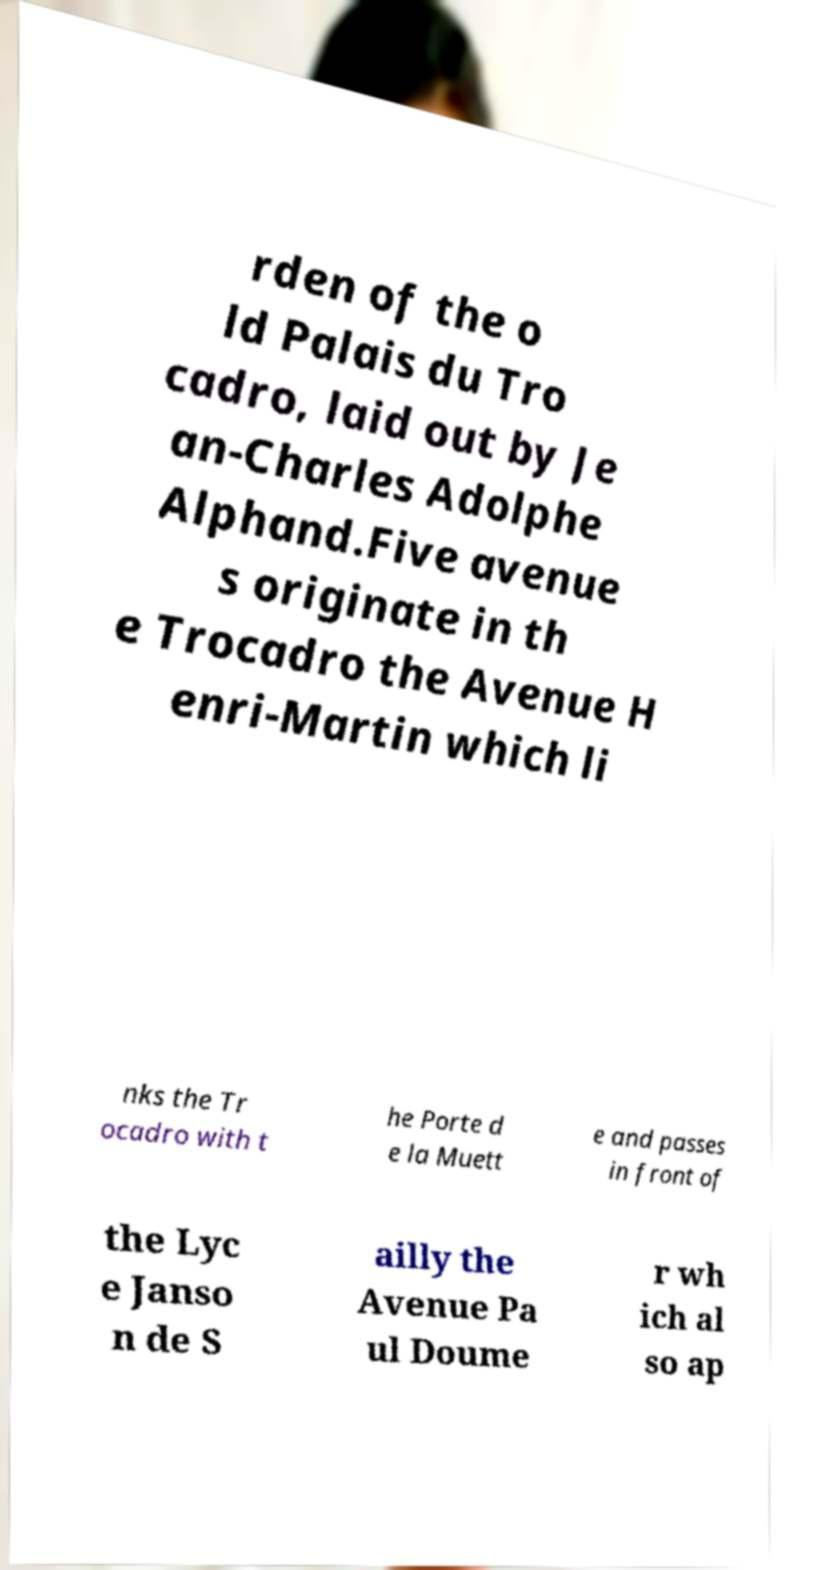What messages or text are displayed in this image? I need them in a readable, typed format. rden of the o ld Palais du Tro cadro, laid out by Je an-Charles Adolphe Alphand.Five avenue s originate in th e Trocadro the Avenue H enri-Martin which li nks the Tr ocadro with t he Porte d e la Muett e and passes in front of the Lyc e Janso n de S ailly the Avenue Pa ul Doume r wh ich al so ap 